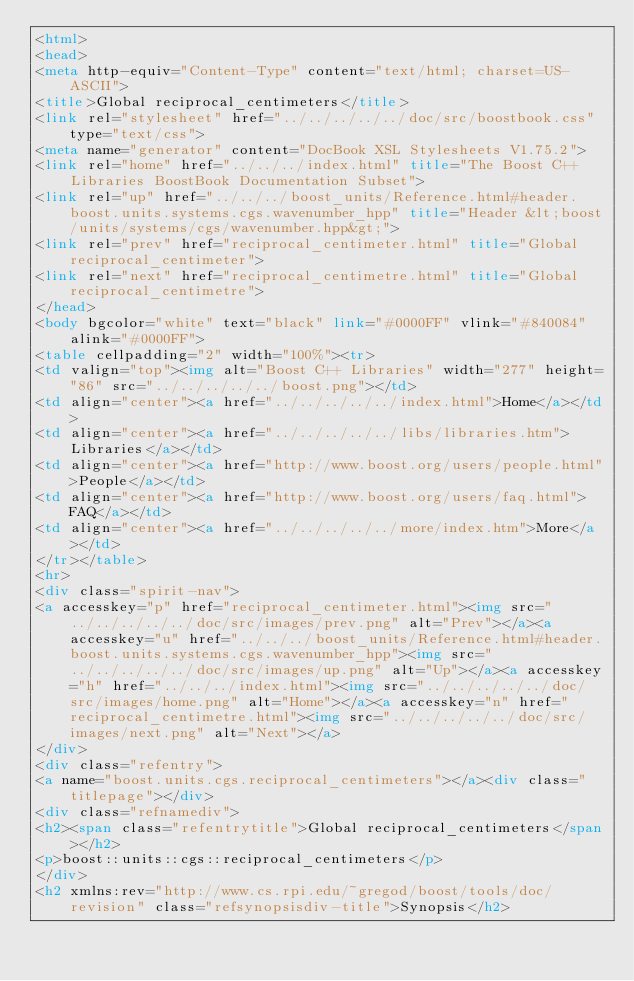Convert code to text. <code><loc_0><loc_0><loc_500><loc_500><_HTML_><html>
<head>
<meta http-equiv="Content-Type" content="text/html; charset=US-ASCII">
<title>Global reciprocal_centimeters</title>
<link rel="stylesheet" href="../../../../../doc/src/boostbook.css" type="text/css">
<meta name="generator" content="DocBook XSL Stylesheets V1.75.2">
<link rel="home" href="../../../index.html" title="The Boost C++ Libraries BoostBook Documentation Subset">
<link rel="up" href="../../../boost_units/Reference.html#header.boost.units.systems.cgs.wavenumber_hpp" title="Header &lt;boost/units/systems/cgs/wavenumber.hpp&gt;">
<link rel="prev" href="reciprocal_centimeter.html" title="Global reciprocal_centimeter">
<link rel="next" href="reciprocal_centimetre.html" title="Global reciprocal_centimetre">
</head>
<body bgcolor="white" text="black" link="#0000FF" vlink="#840084" alink="#0000FF">
<table cellpadding="2" width="100%"><tr>
<td valign="top"><img alt="Boost C++ Libraries" width="277" height="86" src="../../../../../boost.png"></td>
<td align="center"><a href="../../../../../index.html">Home</a></td>
<td align="center"><a href="../../../../../libs/libraries.htm">Libraries</a></td>
<td align="center"><a href="http://www.boost.org/users/people.html">People</a></td>
<td align="center"><a href="http://www.boost.org/users/faq.html">FAQ</a></td>
<td align="center"><a href="../../../../../more/index.htm">More</a></td>
</tr></table>
<hr>
<div class="spirit-nav">
<a accesskey="p" href="reciprocal_centimeter.html"><img src="../../../../../doc/src/images/prev.png" alt="Prev"></a><a accesskey="u" href="../../../boost_units/Reference.html#header.boost.units.systems.cgs.wavenumber_hpp"><img src="../../../../../doc/src/images/up.png" alt="Up"></a><a accesskey="h" href="../../../index.html"><img src="../../../../../doc/src/images/home.png" alt="Home"></a><a accesskey="n" href="reciprocal_centimetre.html"><img src="../../../../../doc/src/images/next.png" alt="Next"></a>
</div>
<div class="refentry">
<a name="boost.units.cgs.reciprocal_centimeters"></a><div class="titlepage"></div>
<div class="refnamediv">
<h2><span class="refentrytitle">Global reciprocal_centimeters</span></h2>
<p>boost::units::cgs::reciprocal_centimeters</p>
</div>
<h2 xmlns:rev="http://www.cs.rpi.edu/~gregod/boost/tools/doc/revision" class="refsynopsisdiv-title">Synopsis</h2></code> 